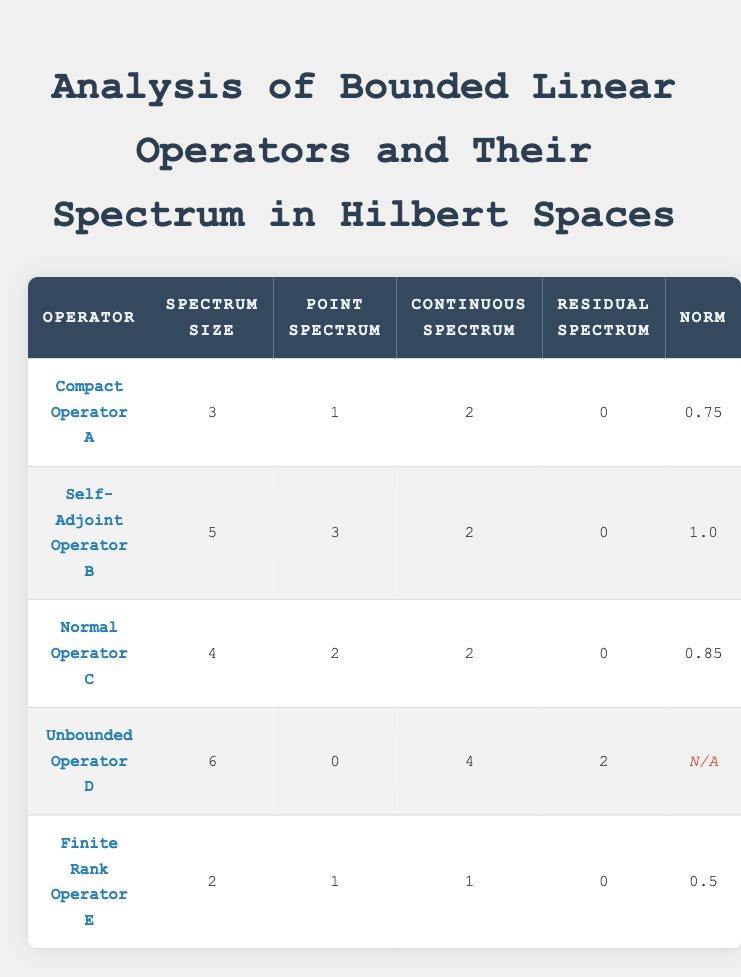What is the spectrum size of Self-Adjoint Operator B? The table indicates that the spectrum size for Self-Adjoint Operator B is directly listed under the "Spectrum Size" column. It shows 5.
Answer: 5 How many operators have a residual spectrum of 0? To find the number of operators with a residual spectrum of 0, we can scan the "Residual Spectrum" column and count the occurrences of 0. In the table, Compact Operator A, Self-Adjoint Operator B, Normal Operator C, and Finite Rank Operator E have a residual spectrum of 0. That gives us a total of 4.
Answer: 4 What is the average norm value of all bounded operators listed? First, we gather the norm values from the table: 0.75, 1.0, 0.85, 0.5. We note that Unbounded Operator D has no norm value listed (N/A), so we exclude it from the average calculation. The sum of the valid norms is 0.75 + 1.0 + 0.85 + 0.5 = 3.1. We then divide by the number of operators with valid norms, which is 4. Thus, the average is 3.1 / 4 = 0.775.
Answer: 0.775 Is there any operator with a point spectrum equal to 0? Looking at the table, we can check the "Point Spectrum" column for any zero values. We see that Unbounded Operator D has a point spectrum of 0. Thus, the answer is yes.
Answer: Yes Which operator has the highest spectrum size, and what is that size? To find the operator with the highest spectrum size, we can compare the "Spectrum Size" values across all operators listed. The largest value in that column is 6, which belongs to Unbounded Operator D.
Answer: Unbounded Operator D, 6 What is the difference between the largest and smallest spectrum sizes? First, we identify the largest spectrum size, which is 6 (for Unbounded Operator D), and the smallest spectrum size, which is 2 (for Finite Rank Operator E). The difference is calculated by subtracting the smallest from the largest: 6 - 2 = 4.
Answer: 4 Are there any operators with both a continuous spectrum and a residual spectrum greater than 0? We need to examine the "Continuous Spectrum" and "Residual Spectrum" columns. Only Unbounded Operator D possesses a continuous spectrum of 4 and a residual spectrum of 2. Therefore, it meets the criteria.
Answer: Yes 